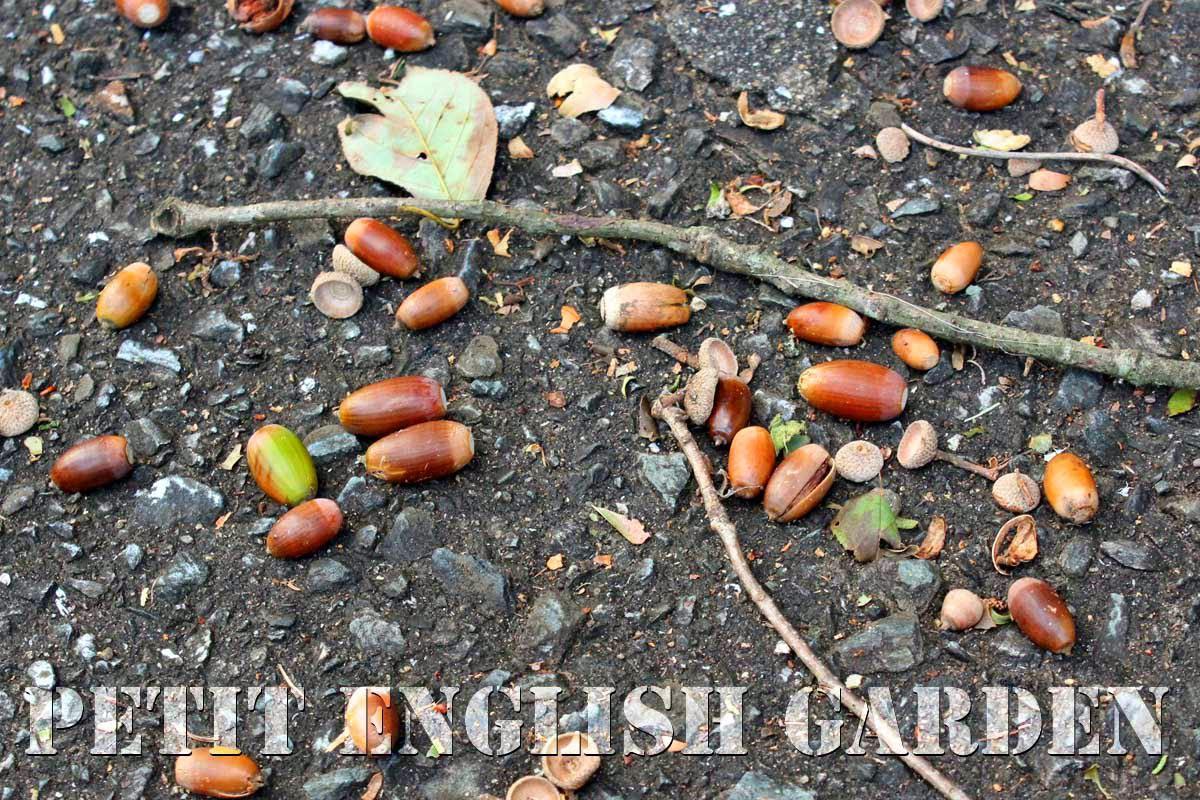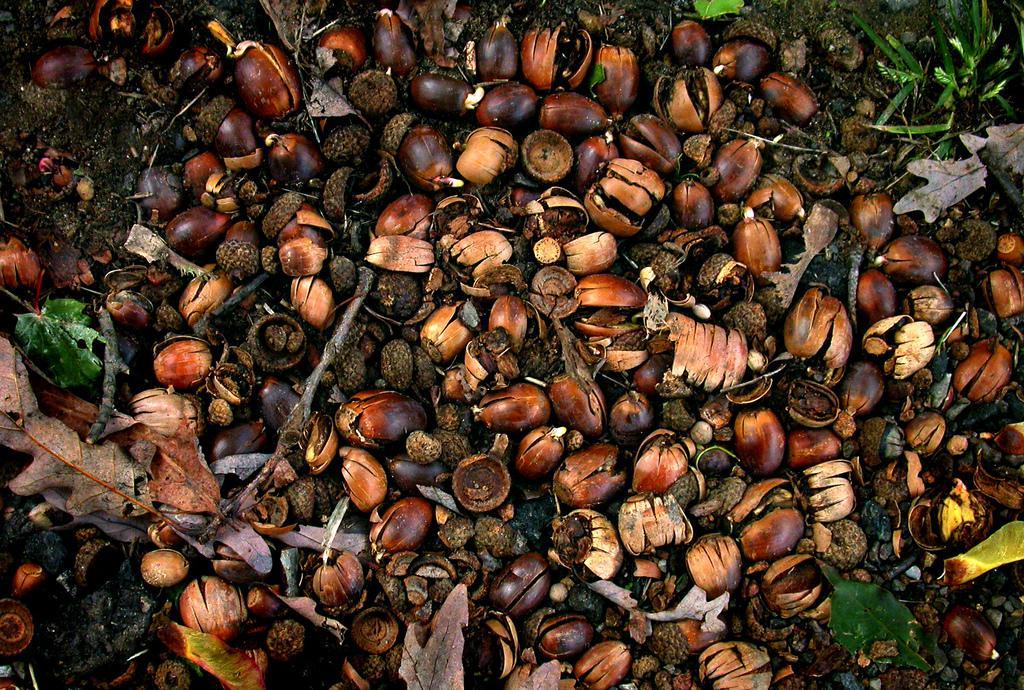The first image is the image on the left, the second image is the image on the right. Assess this claim about the two images: "In the image to the right, there is no green grass; there is merely one spot which contains a green plant at all.". Correct or not? Answer yes or no. No. The first image is the image on the left, the second image is the image on the right. Analyze the images presented: Is the assertion "One image includes at least six recognizable autumn oak leaves amid a pile of fallen brown acorns and their separated caps." valid? Answer yes or no. No. 